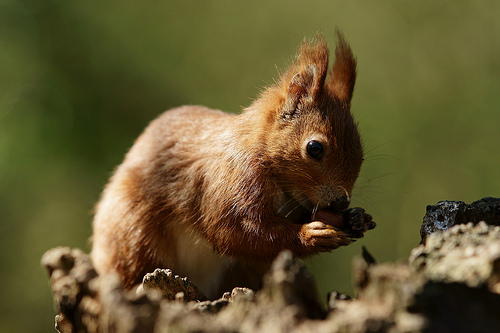<image>
Can you confirm if the squirrel is behind the background? No. The squirrel is not behind the background. From this viewpoint, the squirrel appears to be positioned elsewhere in the scene. Is there a animal above the tree? No. The animal is not positioned above the tree. The vertical arrangement shows a different relationship. 